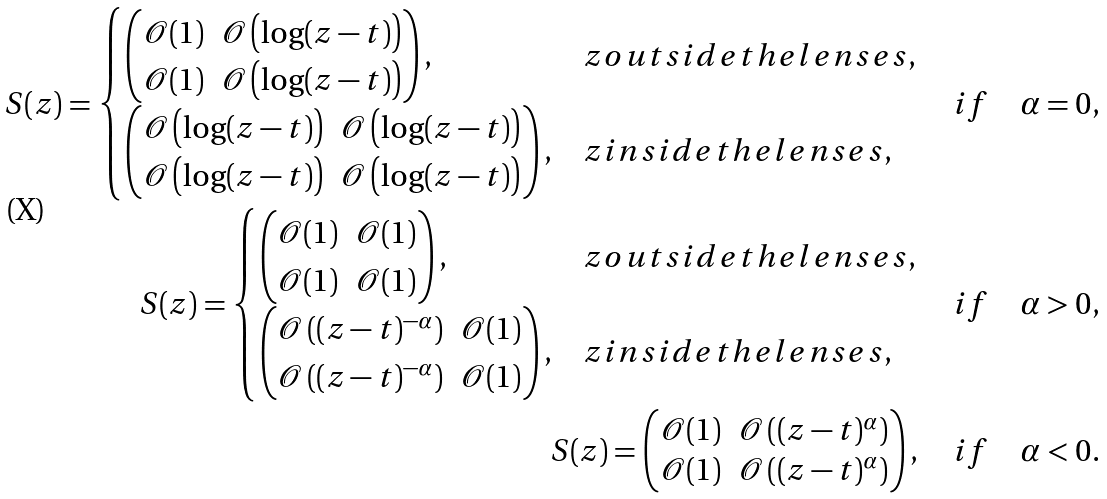Convert formula to latex. <formula><loc_0><loc_0><loc_500><loc_500>S ( z ) = \begin{cases} \begin{pmatrix} \mathcal { O } ( 1 ) & \mathcal { O } \left ( \log ( z - t ) \right ) \\ \mathcal { O } ( 1 ) & \mathcal { O } \left ( \log ( z - t ) \right ) \end{pmatrix} , & z o u t s i d e t h e l e n s e s , \\ \begin{pmatrix} \mathcal { O } \left ( \log ( z - t ) \right ) & \mathcal { O } \left ( \log ( z - t ) \right ) \\ \mathcal { O } \left ( \log ( z - t ) \right ) & \mathcal { O } \left ( \log ( z - t ) \right ) \end{pmatrix} , & z i n s i d e t h e l e n s e s , \end{cases} \quad i f \quad \alpha = 0 , \\ S ( z ) = \begin{cases} \begin{pmatrix} \mathcal { O } ( 1 ) & \mathcal { O } ( 1 ) \\ \mathcal { O } ( 1 ) & \mathcal { O } ( 1 ) \end{pmatrix} , & z o u t s i d e t h e l e n s e s , \\ \begin{pmatrix} \mathcal { O } \left ( ( z - t ) ^ { - \alpha } \right ) & \mathcal { O } ( 1 ) \\ \mathcal { O } \left ( ( z - t ) ^ { - \alpha } \right ) & \mathcal { O } ( 1 ) \end{pmatrix} , & z i n s i d e t h e l e n s e s , \end{cases} \quad i f \quad \alpha > 0 , \\ S ( z ) = \begin{pmatrix} \mathcal { O } ( 1 ) & \mathcal { O } \left ( ( z - t ) ^ { \alpha } \right ) \\ \mathcal { O } ( 1 ) & \mathcal { O } \left ( ( z - t ) ^ { \alpha } \right ) \end{pmatrix} , \quad i f \quad \alpha < 0 .</formula> 